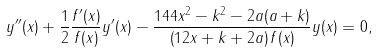Convert formula to latex. <formula><loc_0><loc_0><loc_500><loc_500>y ^ { \prime \prime } ( x ) + \frac { 1 } { 2 } \frac { f ^ { \prime } ( x ) } { f ( x ) } y ^ { \prime } ( x ) - \frac { 1 4 4 x ^ { 2 } - k ^ { 2 } - 2 a ( a + k ) } { \left ( 1 2 x + k + 2 a \right ) f ( x ) } y ( x ) = 0 ,</formula> 